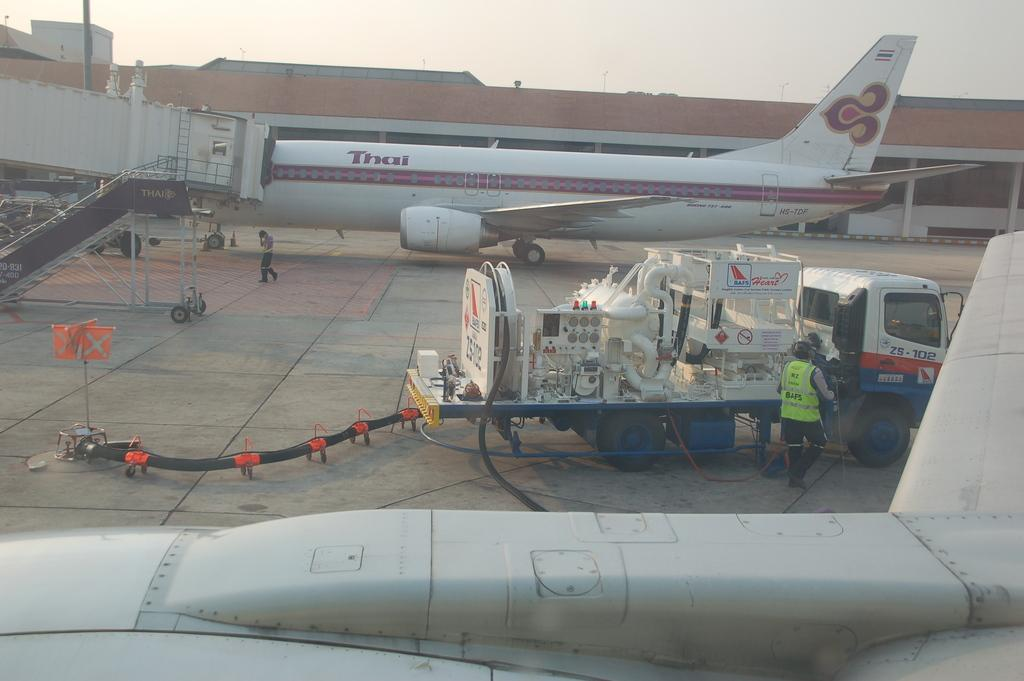What is the main subject of the image? The main subject of the image is an aeroplane. What other objects or structures can be seen in the image? There is a motor vehicle with pipelines, persons standing on the floor, a building, and the sky is visible in the image. What type of lead is being used by the persons standing on the floor in the image? There is no lead present in the image, nor is there any indication that the persons standing on the floor are using any type of lead. 